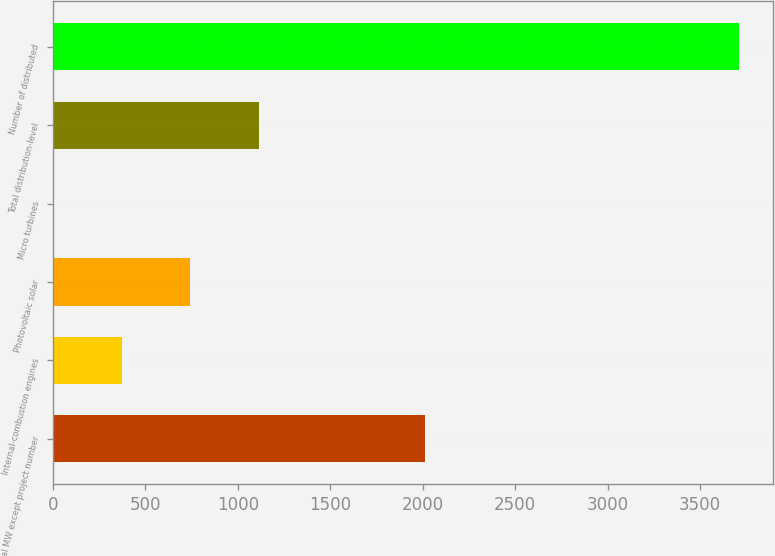Convert chart. <chart><loc_0><loc_0><loc_500><loc_500><bar_chart><fcel>Total MW except project number<fcel>Internal-combustion engines<fcel>Photovoltaic solar<fcel>Micro turbines<fcel>Total distribution-level<fcel>Number of distributed<nl><fcel>2015<fcel>371.8<fcel>742.6<fcel>1<fcel>1113.4<fcel>3709<nl></chart> 